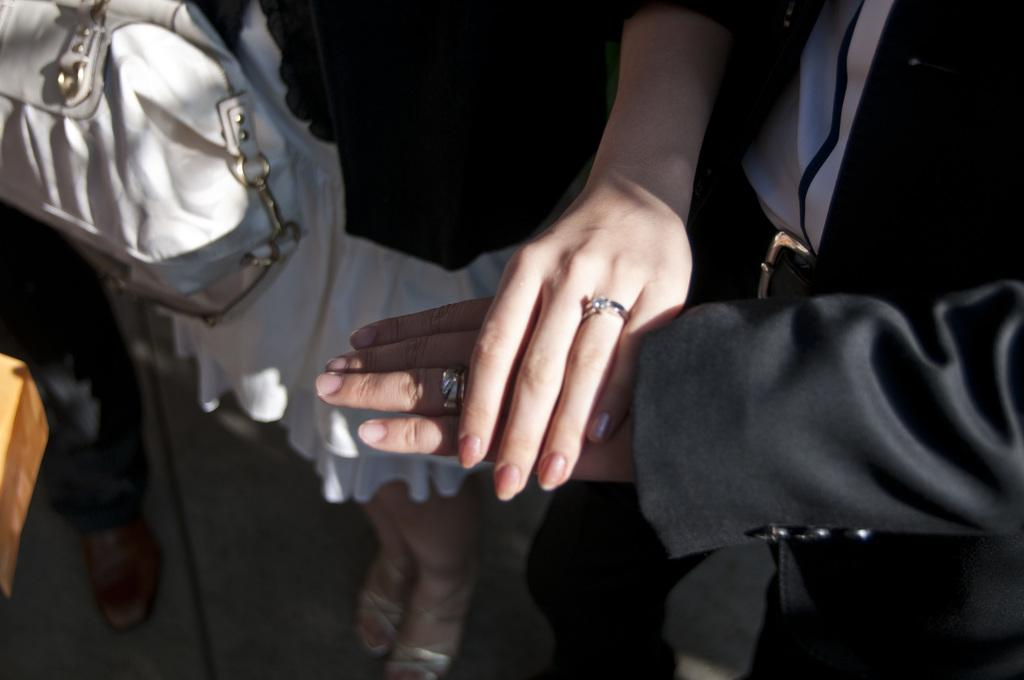Who is present in the image? There is a woman in the image. What is the woman wearing? The woman is wearing a black and white dress. What is the woman doing in the image? The woman is putting her hand on the hand of a man. What is the man wearing in the image? The man is wearing a black blazer. What type of accessory can be seen in the image? There is a white bag in the image. Whose leg is visible in the image? The leg of a person is visible in the image. What type of dog can be seen in the image? There is no dog present in the image. How does the woman feel about the man's view on the topic? The image does not provide any information about the woman's feelings or the man's view on a topic. 